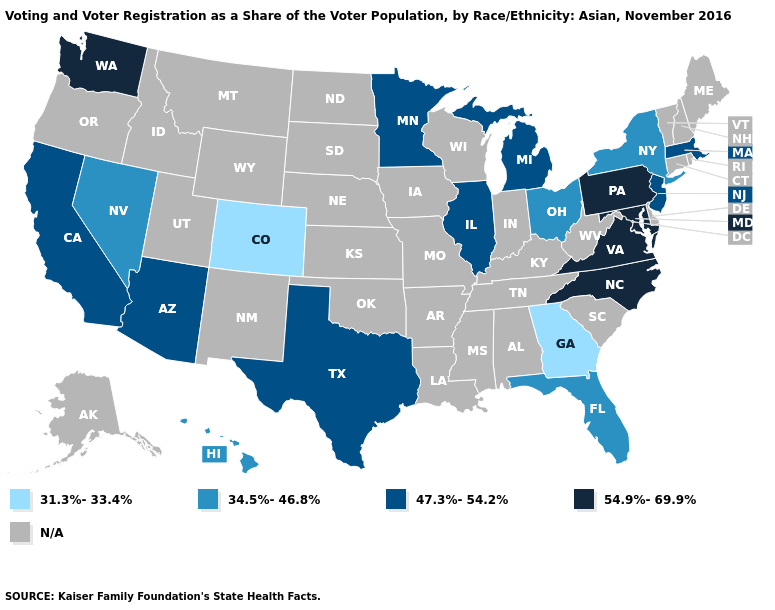What is the value of Massachusetts?
Be succinct. 47.3%-54.2%. Does the map have missing data?
Be succinct. Yes. Name the states that have a value in the range 47.3%-54.2%?
Concise answer only. Arizona, California, Illinois, Massachusetts, Michigan, Minnesota, New Jersey, Texas. What is the highest value in the USA?
Keep it brief. 54.9%-69.9%. Does the first symbol in the legend represent the smallest category?
Short answer required. Yes. Which states have the lowest value in the West?
Quick response, please. Colorado. Which states have the lowest value in the USA?
Quick response, please. Colorado, Georgia. Does Illinois have the lowest value in the MidWest?
Be succinct. No. What is the lowest value in states that border Oklahoma?
Answer briefly. 31.3%-33.4%. Name the states that have a value in the range 54.9%-69.9%?
Be succinct. Maryland, North Carolina, Pennsylvania, Virginia, Washington. What is the value of New York?
Answer briefly. 34.5%-46.8%. Does Florida have the lowest value in the USA?
Short answer required. No. 